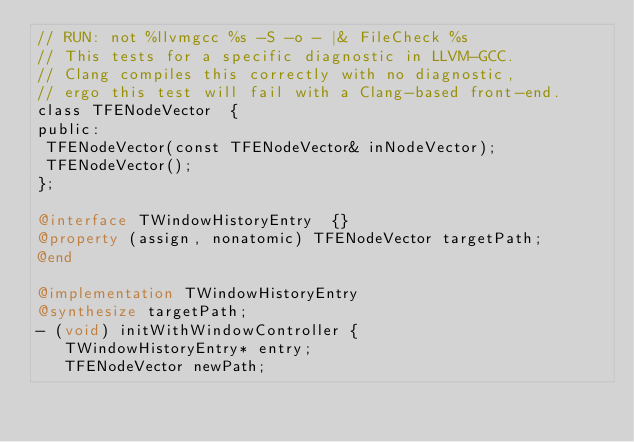<code> <loc_0><loc_0><loc_500><loc_500><_ObjectiveC_>// RUN: not %llvmgcc %s -S -o - |& FileCheck %s
// This tests for a specific diagnostic in LLVM-GCC.
// Clang compiles this correctly with no diagnostic,
// ergo this test will fail with a Clang-based front-end.
class TFENodeVector  {
public:
 TFENodeVector(const TFENodeVector& inNodeVector);
 TFENodeVector();
};

@interface TWindowHistoryEntry  {}
@property (assign, nonatomic) TFENodeVector targetPath;
@end

@implementation TWindowHistoryEntry
@synthesize targetPath;
- (void) initWithWindowController {
   TWindowHistoryEntry* entry;
   TFENodeVector newPath;</code> 